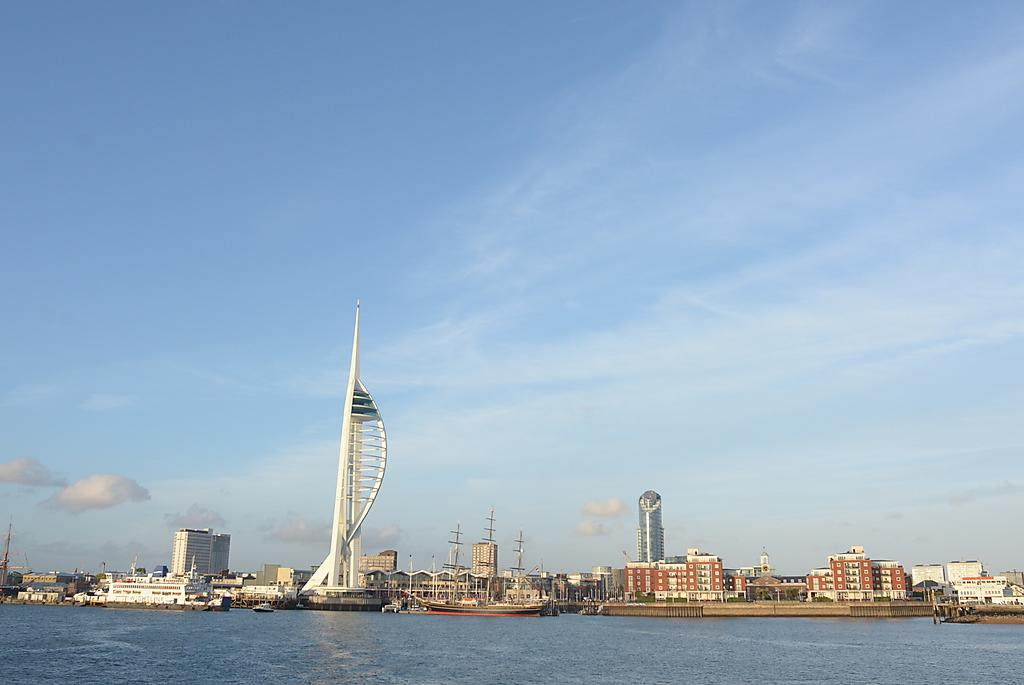Where was the image taken? The image was taken in an ocean. What can be seen in the background of the image? There are buildings and skyscrapers in the background. What is visible in the sky in the image? There are clouds visible in the sky. Can you see any squirrels climbing the buildings in the image? There are no squirrels visible in the image; it features an ocean view with buildings and skyscrapers in the background. 